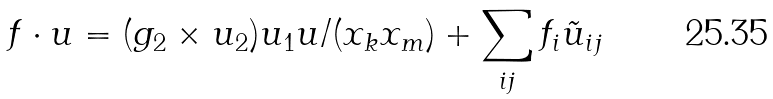<formula> <loc_0><loc_0><loc_500><loc_500>f \cdot u = ( g _ { 2 } \times u _ { 2 } ) u _ { 1 } u / ( x _ { k } x _ { m } ) + \sum _ { i j } f _ { i } \tilde { u } _ { i j }</formula> 